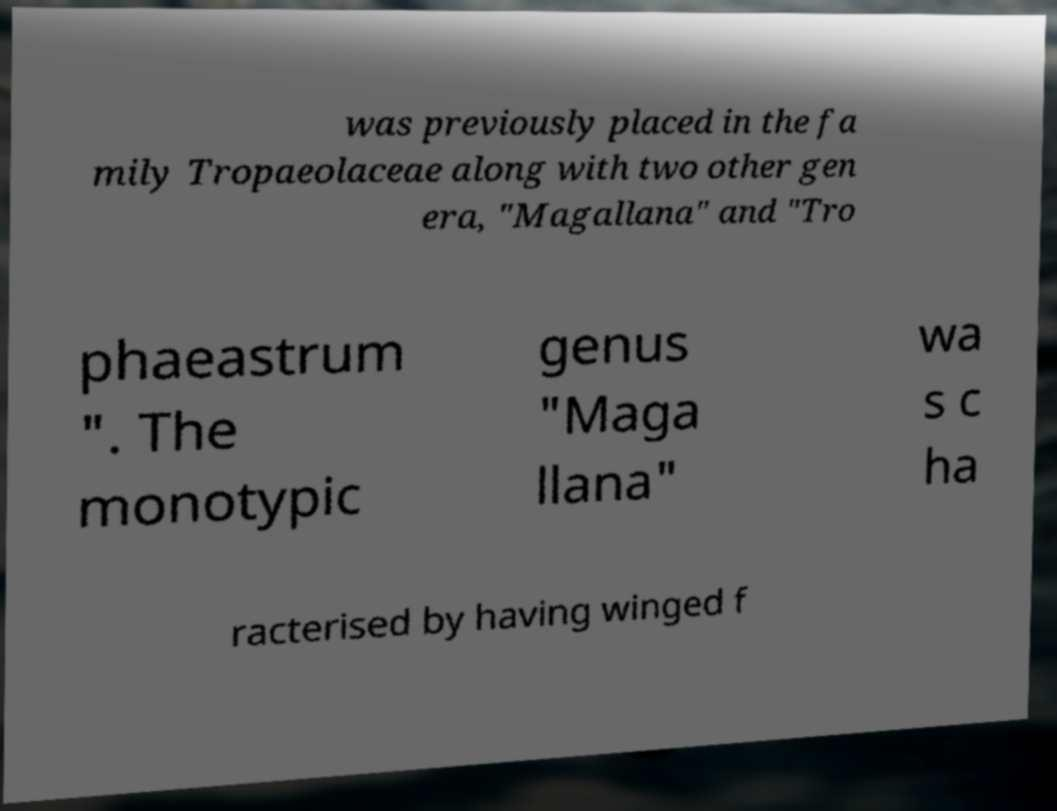Please identify and transcribe the text found in this image. was previously placed in the fa mily Tropaeolaceae along with two other gen era, "Magallana" and "Tro phaeastrum ". The monotypic genus "Maga llana" wa s c ha racterised by having winged f 